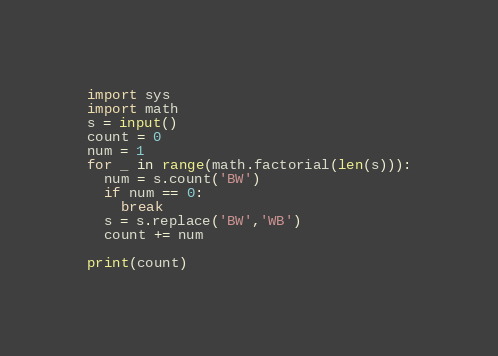<code> <loc_0><loc_0><loc_500><loc_500><_Python_>import sys
import math
s = input()
count = 0
num = 1
for _ in range(math.factorial(len(s))):
  num = s.count('BW')
  if num == 0:
    break
  s = s.replace('BW','WB')
  count += num
  
print(count)</code> 